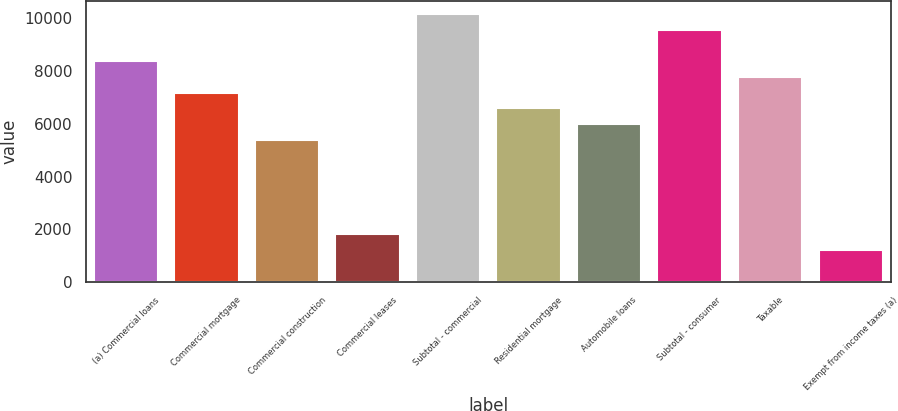Convert chart. <chart><loc_0><loc_0><loc_500><loc_500><bar_chart><fcel>(a) Commercial loans<fcel>Commercial mortgage<fcel>Commercial construction<fcel>Commercial leases<fcel>Subtotal - commercial<fcel>Residential mortgage<fcel>Automobile loans<fcel>Subtotal - consumer<fcel>Taxable<fcel>Exempt from income taxes (a)<nl><fcel>8365<fcel>7173<fcel>5385<fcel>1809<fcel>10153<fcel>6577<fcel>5981<fcel>9557<fcel>7769<fcel>1213<nl></chart> 